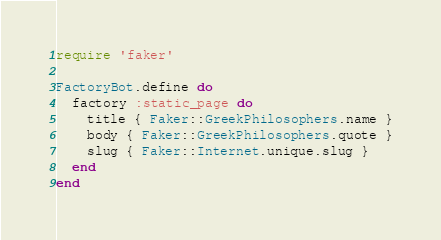Convert code to text. <code><loc_0><loc_0><loc_500><loc_500><_Ruby_>require 'faker'

FactoryBot.define do
  factory :static_page do
    title { Faker::GreekPhilosophers.name }
    body { Faker::GreekPhilosophers.quote }
    slug { Faker::Internet.unique.slug }
  end
end
</code> 